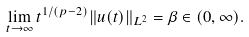Convert formula to latex. <formula><loc_0><loc_0><loc_500><loc_500>\lim _ { t \to \infty } t ^ { 1 / ( p - 2 ) } \| u ( t ) \| _ { L ^ { 2 } } = \beta \in ( 0 , \infty ) .</formula> 